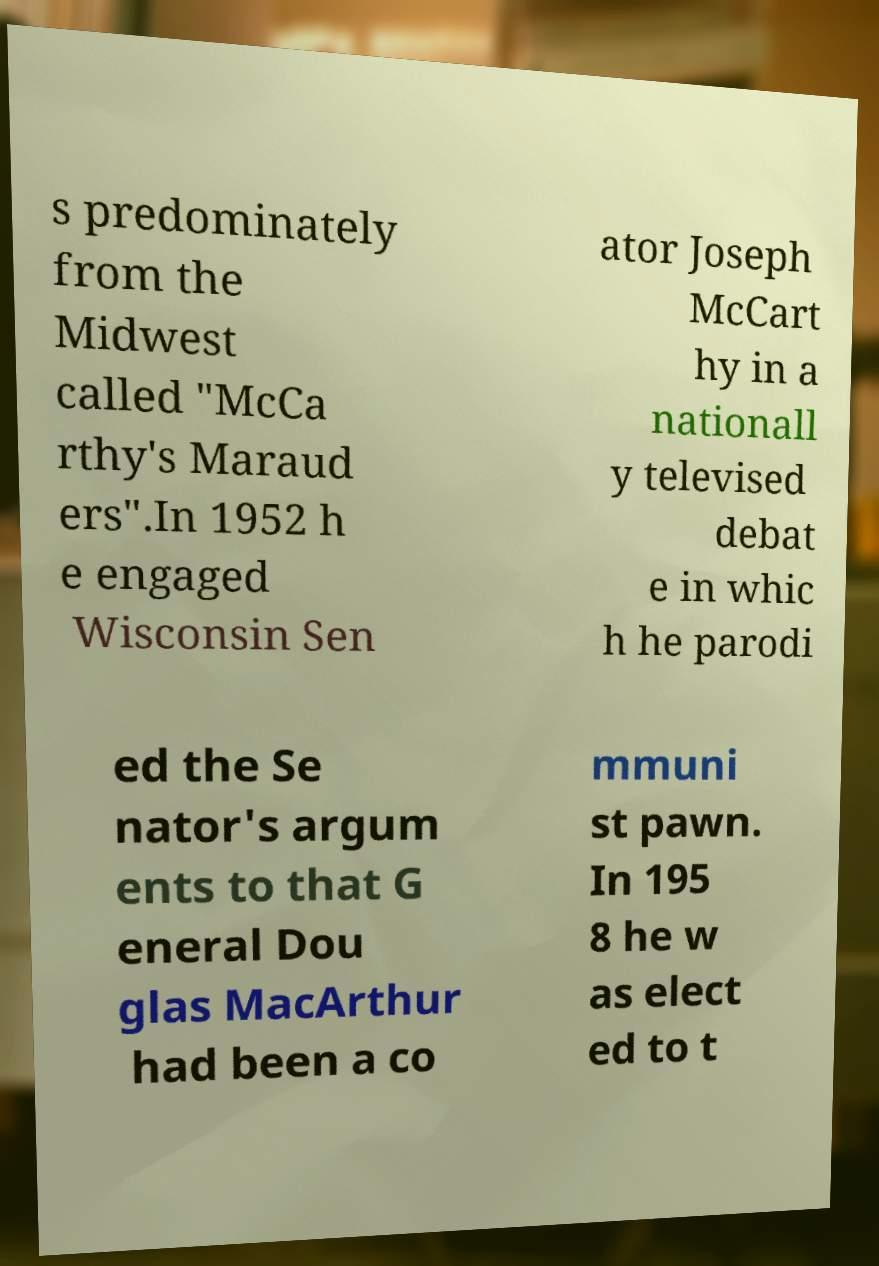For documentation purposes, I need the text within this image transcribed. Could you provide that? s predominately from the Midwest called "McCa rthy's Maraud ers".In 1952 h e engaged Wisconsin Sen ator Joseph McCart hy in a nationall y televised debat e in whic h he parodi ed the Se nator's argum ents to that G eneral Dou glas MacArthur had been a co mmuni st pawn. In 195 8 he w as elect ed to t 